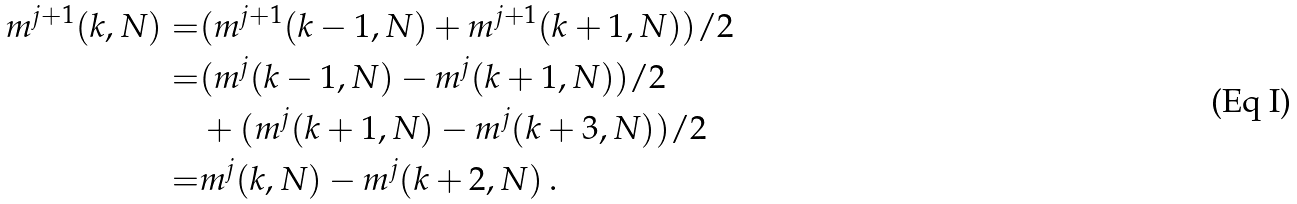Convert formula to latex. <formula><loc_0><loc_0><loc_500><loc_500>m ^ { j + 1 } ( k , N ) = & ( m ^ { j + 1 } ( k - 1 , N ) + m ^ { j + 1 } ( k + 1 , N ) ) / 2 \\ = & ( m ^ { j } ( k - 1 , N ) - m ^ { j } ( k + 1 , N ) ) / 2 \\ & + ( m ^ { j } ( k + 1 , N ) - m ^ { j } ( k + 3 , N ) ) / 2 \\ = & m ^ { j } ( k , N ) - m ^ { j } ( k + 2 , N ) \, .</formula> 